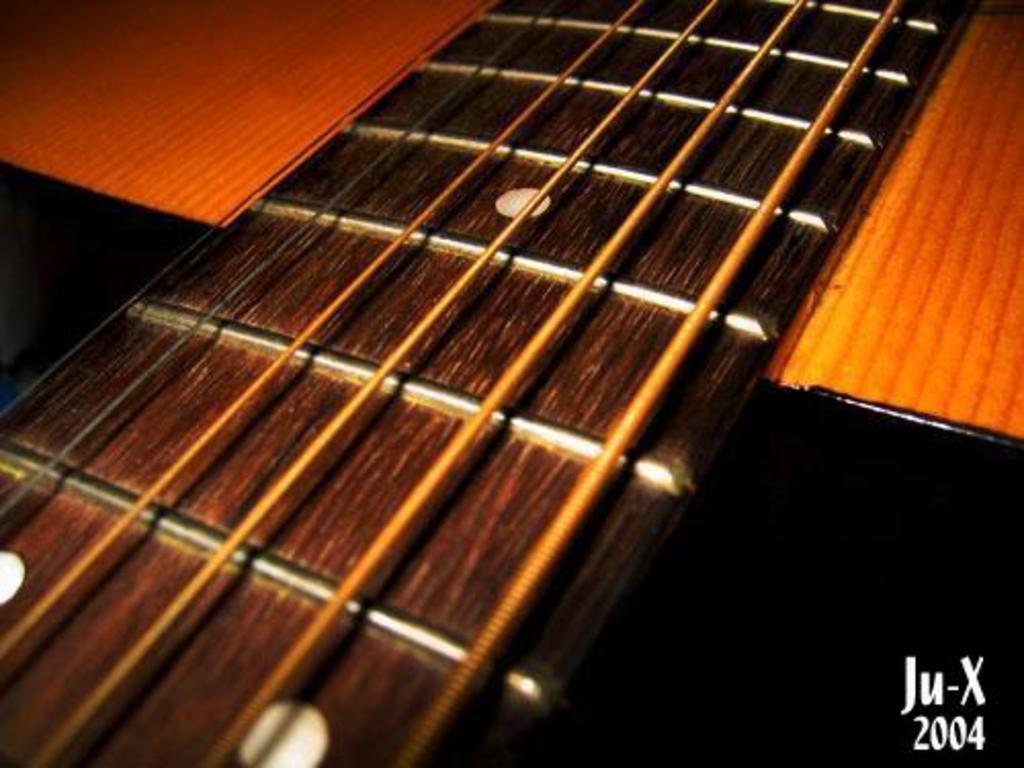Please provide a concise description of this image. In this picture we can see a wooden platform with strings on it and some round shaped holes and this is looking like a guitar strings. 